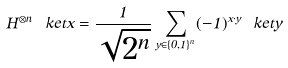Convert formula to latex. <formula><loc_0><loc_0><loc_500><loc_500>H ^ { \otimes n } \ k e t { x } = \frac { 1 } { \sqrt { 2 ^ { n } } } \sum _ { y \in \{ 0 , 1 \} ^ { n } } ( - 1 ) ^ { x \cdot y } \ k e t { y }</formula> 